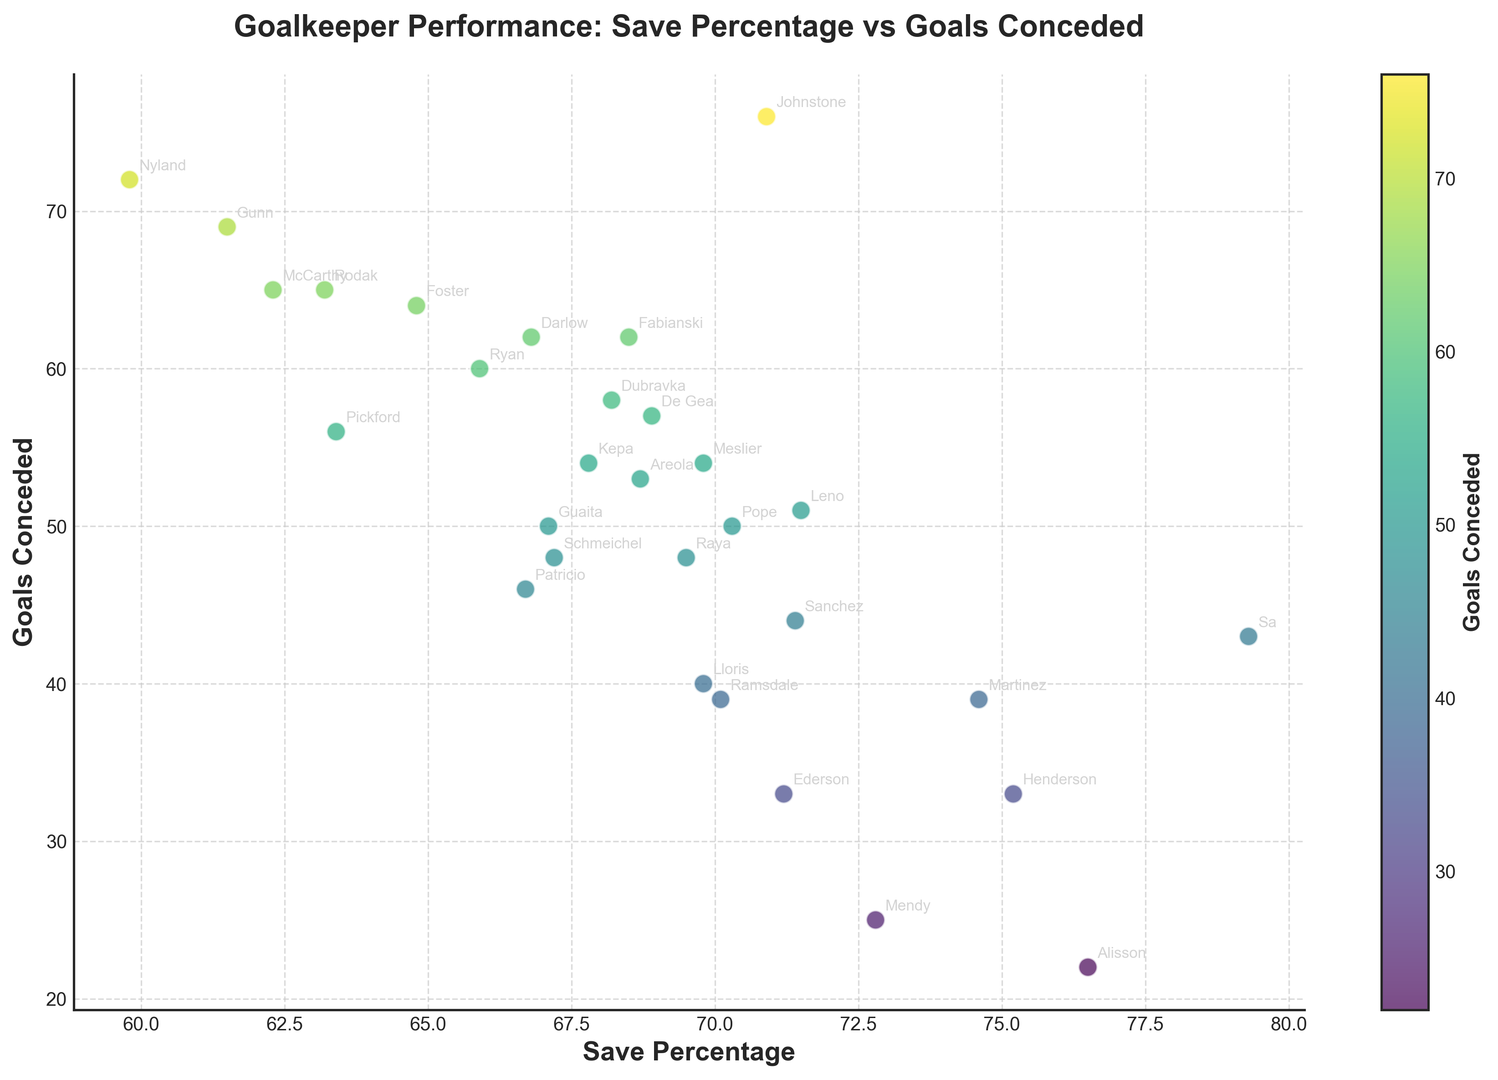Which goalkeeper has the highest save percentage? The save percentages are displayed along the x-axis. By locating the point furthest to the right, it's evident that Sa has the highest save percentage of 79.3%.
Answer: Sa How many goalkeepers have conceded fewer than 30 goals? The goals conceded are displayed along the y-axis. By counting the points below the 30-goal mark, you find that Alisson and Mendy have conceded fewer than 30 goals.
Answer: 2 Who are the goalkeepers with a save percentage higher than 75%? Locate the points on the scatter plot to the right of the 75% mark on the x-axis. The goalkeepers in this range are Alisson, Henderson, and Sa.
Answer: Alisson, Henderson, Sa What is the difference in goals conceded between De Gea and Mendy? Identify the goals conceded by De Gea (57) and Mendy (25) from the plot and subtract the two values: 57 - 25 = 32.
Answer: 32 Who has conceded the most goals with a save percentage above 70%? Look for goalkeepers above the 70% save rate mark on the x-axis and compare who has the highest value on the y-axis. Johnstone appears with 76 goals conceded.
Answer: Johnstone Which goalkeeper has the closest save percentage to Kepa? Locate Kepa on the x-axis with a save percentage of 67.8%. The nearest point horizontally is Schmeichel at 67.2%.
Answer: Schmeichel What is the mean number of goals conceded among goalkeepers with a save percentage below 65%? Identify goalkeepers below the 65% save rate: Pickford (56), Foster (64), McCarthy (65), Darlow (62), Gunn (69), Nyland (72), Rodak (65). Total goals conceded: 56 + 64 + 65 + 62 + 69 + 72 + 65 = 453. Count of goalkeepers: 7. Then, 453 / 7 = 64.71.
Answer: 64.71 Do goalkeepers with higher save percentages tend to concede fewer goals? Examine the general trend in the scatter plot. Higher save percentages (to the right) generally align with lower goals conceded (lower on the y-axis), indicating an inverse relationship.
Answer: Yes Who has the lowest save percentage and how many goals have they conceded? The lowest save percentage is at the leftmost point of the plot, which belongs to Nyland with a save percentage of 59.8%. Nyland has conceded 72 goals.
Answer: Nyland, 72 What's the median save percentage among all goalkeepers? Sort the save percentages and find the middle value. Median of (59.8, 61.5, 62.3, 63.2, 63.4, 64.8, 65.9, 66.7, 66.8, 67.1, 67.2, 67.8, 68.2, 68.5, 68.7, 68.9, 69.5, 69.8, 69.8, 70.1, 70.3, 70.9, 71.2, 71.4, 71.5, 72.8, 74.6, 75.2, 76.5, 79.3) is the middle value at index 15 and 16 which averages out to (69.5 + 69.8)/2 = 69.65%.
Answer: 69.65% 